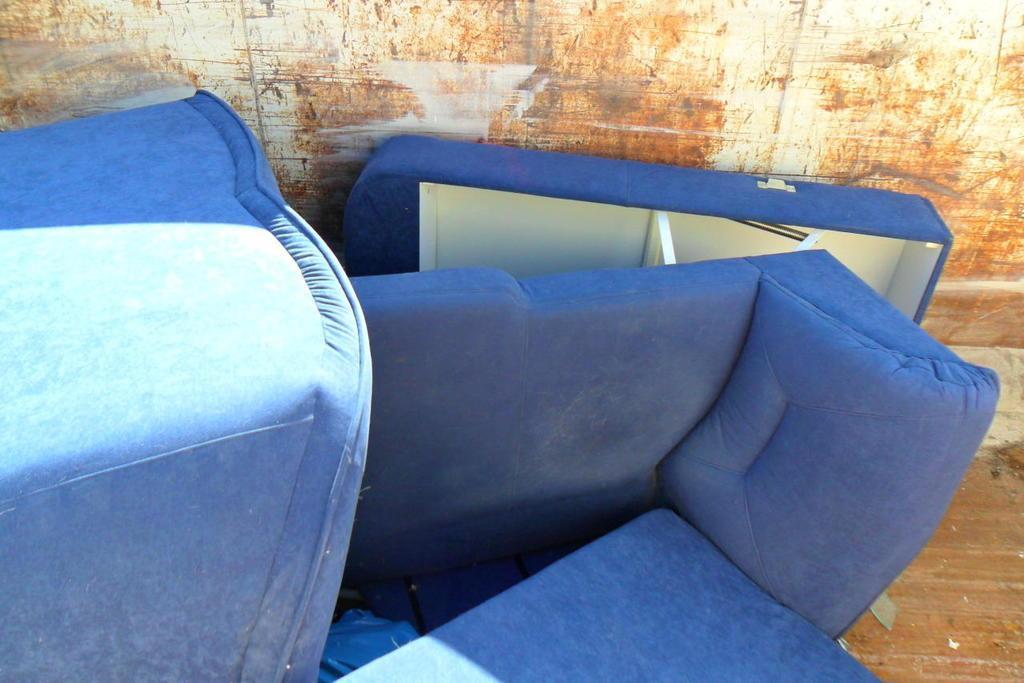Describe this image in one or two sentences. On the background i guess it's a rusted wall. Here we can see couches in blue colour. 